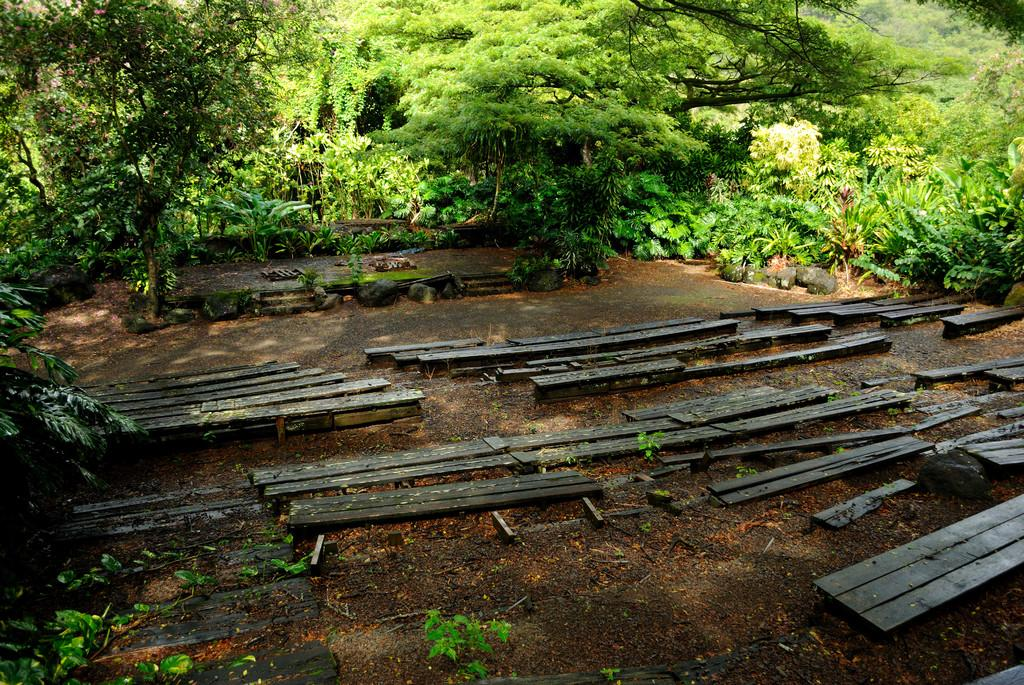What type of seating is available on the path in the image? There are wooden benches on the path. What can be seen in front of the wooden benches? There are plants and trees in front of the wooden benches. What type of cap is the sun wearing in the image? There is no sun or cap present in the image. Are there any slaves depicted in the image? There is no reference to any slaves in the image. 